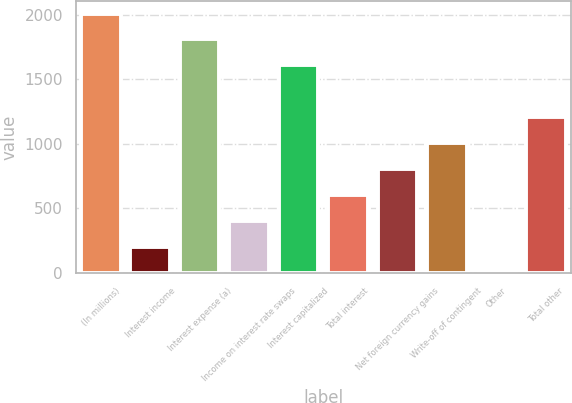<chart> <loc_0><loc_0><loc_500><loc_500><bar_chart><fcel>(In millions)<fcel>Interest income<fcel>Interest expense (a)<fcel>Income on interest rate swaps<fcel>Interest capitalized<fcel>Total interest<fcel>Net foreign currency gains<fcel>Write-off of contingent<fcel>Other<fcel>Total other<nl><fcel>2009<fcel>201.8<fcel>1808.2<fcel>402.6<fcel>1607.4<fcel>603.4<fcel>804.2<fcel>1005<fcel>1<fcel>1205.8<nl></chart> 